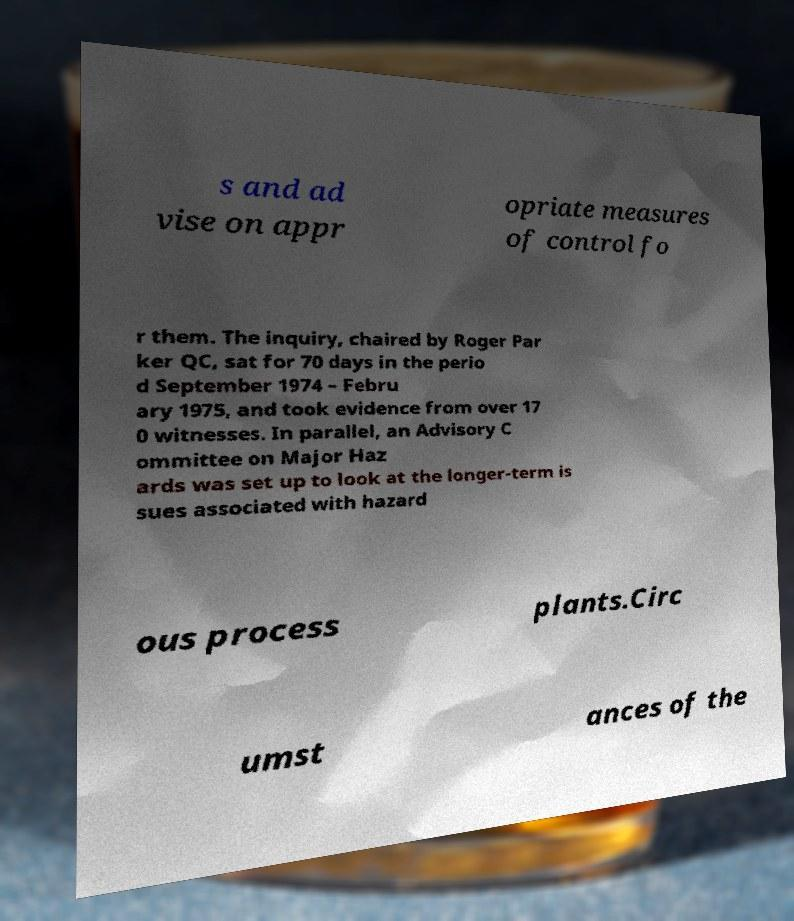Please identify and transcribe the text found in this image. s and ad vise on appr opriate measures of control fo r them. The inquiry, chaired by Roger Par ker QC, sat for 70 days in the perio d September 1974 – Febru ary 1975, and took evidence from over 17 0 witnesses. In parallel, an Advisory C ommittee on Major Haz ards was set up to look at the longer-term is sues associated with hazard ous process plants.Circ umst ances of the 